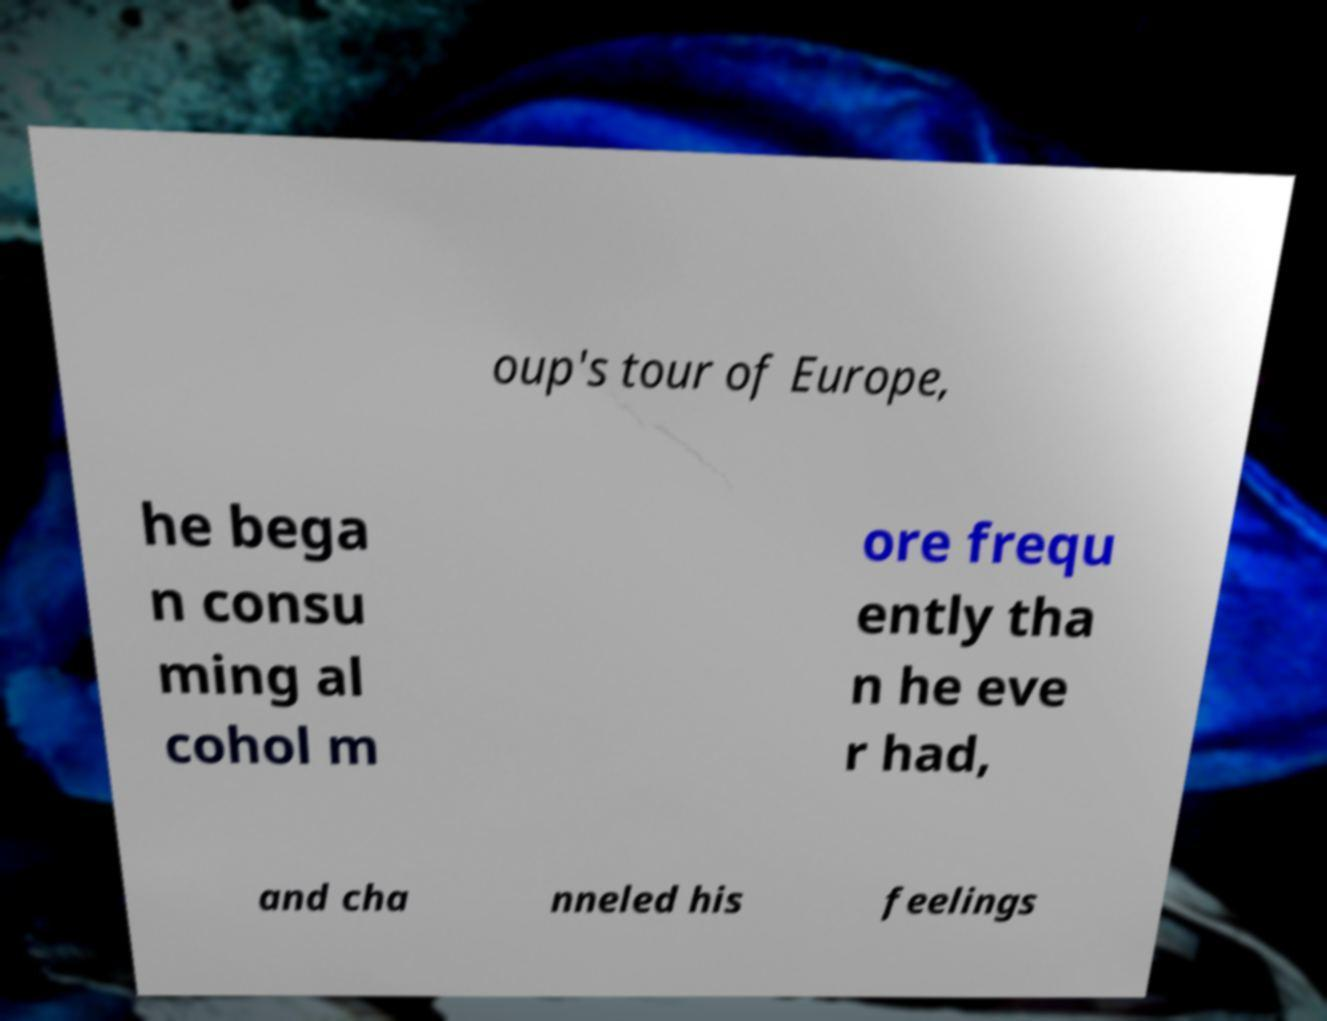Could you extract and type out the text from this image? oup's tour of Europe, he bega n consu ming al cohol m ore frequ ently tha n he eve r had, and cha nneled his feelings 